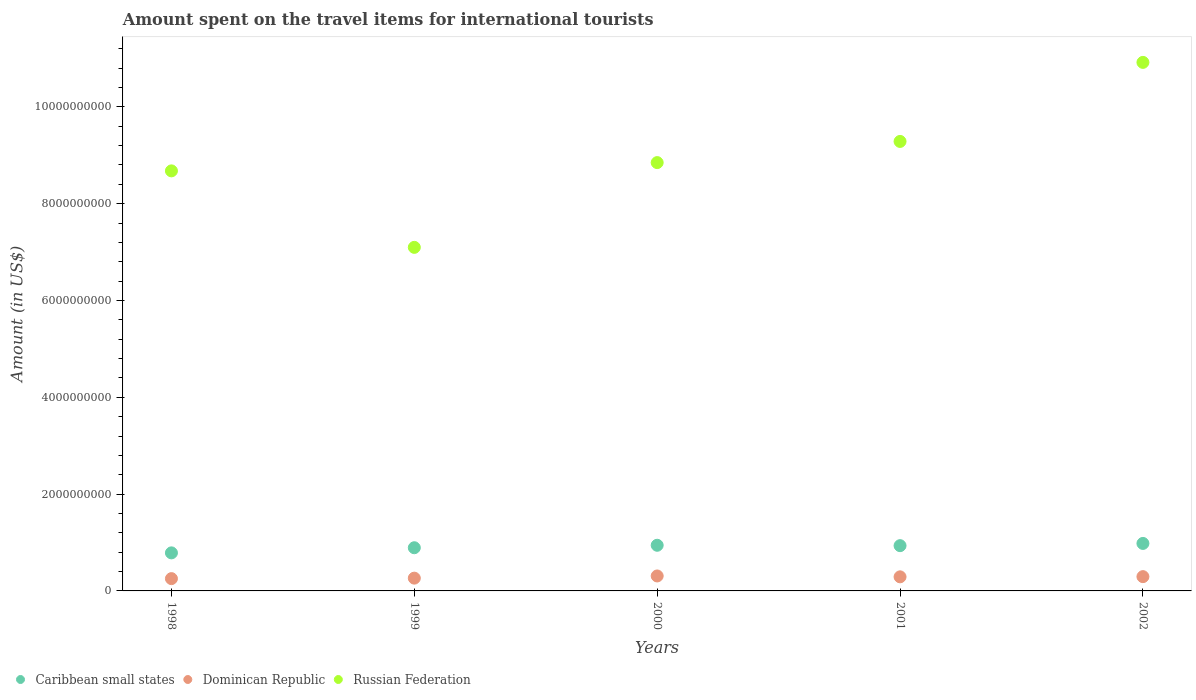How many different coloured dotlines are there?
Provide a short and direct response. 3. What is the amount spent on the travel items for international tourists in Caribbean small states in 2002?
Provide a succinct answer. 9.81e+08. Across all years, what is the maximum amount spent on the travel items for international tourists in Caribbean small states?
Ensure brevity in your answer.  9.81e+08. Across all years, what is the minimum amount spent on the travel items for international tourists in Russian Federation?
Ensure brevity in your answer.  7.10e+09. In which year was the amount spent on the travel items for international tourists in Dominican Republic minimum?
Give a very brief answer. 1998. What is the total amount spent on the travel items for international tourists in Caribbean small states in the graph?
Your answer should be compact. 4.54e+09. What is the difference between the amount spent on the travel items for international tourists in Caribbean small states in 1998 and that in 2002?
Provide a succinct answer. -1.95e+08. What is the difference between the amount spent on the travel items for international tourists in Dominican Republic in 2002 and the amount spent on the travel items for international tourists in Caribbean small states in 2001?
Make the answer very short. -6.40e+08. What is the average amount spent on the travel items for international tourists in Dominican Republic per year?
Give a very brief answer. 2.83e+08. In the year 1999, what is the difference between the amount spent on the travel items for international tourists in Dominican Republic and amount spent on the travel items for international tourists in Russian Federation?
Give a very brief answer. -6.83e+09. What is the ratio of the amount spent on the travel items for international tourists in Dominican Republic in 1999 to that in 2001?
Your response must be concise. 0.91. Is the difference between the amount spent on the travel items for international tourists in Dominican Republic in 2000 and 2001 greater than the difference between the amount spent on the travel items for international tourists in Russian Federation in 2000 and 2001?
Offer a very short reply. Yes. What is the difference between the highest and the second highest amount spent on the travel items for international tourists in Russian Federation?
Provide a succinct answer. 1.63e+09. What is the difference between the highest and the lowest amount spent on the travel items for international tourists in Russian Federation?
Your answer should be compact. 3.82e+09. Is it the case that in every year, the sum of the amount spent on the travel items for international tourists in Russian Federation and amount spent on the travel items for international tourists in Dominican Republic  is greater than the amount spent on the travel items for international tourists in Caribbean small states?
Your response must be concise. Yes. Is the amount spent on the travel items for international tourists in Caribbean small states strictly less than the amount spent on the travel items for international tourists in Russian Federation over the years?
Offer a very short reply. Yes. How many years are there in the graph?
Keep it short and to the point. 5. Are the values on the major ticks of Y-axis written in scientific E-notation?
Ensure brevity in your answer.  No. Does the graph contain any zero values?
Offer a terse response. No. Where does the legend appear in the graph?
Keep it short and to the point. Bottom left. How are the legend labels stacked?
Offer a very short reply. Horizontal. What is the title of the graph?
Provide a succinct answer. Amount spent on the travel items for international tourists. What is the label or title of the X-axis?
Ensure brevity in your answer.  Years. What is the label or title of the Y-axis?
Offer a terse response. Amount (in US$). What is the Amount (in US$) in Caribbean small states in 1998?
Provide a succinct answer. 7.86e+08. What is the Amount (in US$) of Dominican Republic in 1998?
Your answer should be very brief. 2.54e+08. What is the Amount (in US$) of Russian Federation in 1998?
Offer a very short reply. 8.68e+09. What is the Amount (in US$) in Caribbean small states in 1999?
Keep it short and to the point. 8.92e+08. What is the Amount (in US$) in Dominican Republic in 1999?
Give a very brief answer. 2.64e+08. What is the Amount (in US$) of Russian Federation in 1999?
Offer a terse response. 7.10e+09. What is the Amount (in US$) of Caribbean small states in 2000?
Provide a succinct answer. 9.43e+08. What is the Amount (in US$) in Dominican Republic in 2000?
Offer a terse response. 3.09e+08. What is the Amount (in US$) of Russian Federation in 2000?
Your response must be concise. 8.85e+09. What is the Amount (in US$) in Caribbean small states in 2001?
Keep it short and to the point. 9.35e+08. What is the Amount (in US$) of Dominican Republic in 2001?
Ensure brevity in your answer.  2.91e+08. What is the Amount (in US$) of Russian Federation in 2001?
Your answer should be very brief. 9.28e+09. What is the Amount (in US$) of Caribbean small states in 2002?
Your answer should be very brief. 9.81e+08. What is the Amount (in US$) in Dominican Republic in 2002?
Give a very brief answer. 2.95e+08. What is the Amount (in US$) in Russian Federation in 2002?
Provide a short and direct response. 1.09e+1. Across all years, what is the maximum Amount (in US$) of Caribbean small states?
Make the answer very short. 9.81e+08. Across all years, what is the maximum Amount (in US$) of Dominican Republic?
Your answer should be very brief. 3.09e+08. Across all years, what is the maximum Amount (in US$) of Russian Federation?
Your response must be concise. 1.09e+1. Across all years, what is the minimum Amount (in US$) in Caribbean small states?
Offer a very short reply. 7.86e+08. Across all years, what is the minimum Amount (in US$) in Dominican Republic?
Offer a very short reply. 2.54e+08. Across all years, what is the minimum Amount (in US$) in Russian Federation?
Your answer should be compact. 7.10e+09. What is the total Amount (in US$) of Caribbean small states in the graph?
Make the answer very short. 4.54e+09. What is the total Amount (in US$) of Dominican Republic in the graph?
Your answer should be compact. 1.41e+09. What is the total Amount (in US$) of Russian Federation in the graph?
Your response must be concise. 4.48e+1. What is the difference between the Amount (in US$) of Caribbean small states in 1998 and that in 1999?
Provide a succinct answer. -1.06e+08. What is the difference between the Amount (in US$) in Dominican Republic in 1998 and that in 1999?
Your answer should be compact. -1.00e+07. What is the difference between the Amount (in US$) of Russian Federation in 1998 and that in 1999?
Ensure brevity in your answer.  1.58e+09. What is the difference between the Amount (in US$) in Caribbean small states in 1998 and that in 2000?
Keep it short and to the point. -1.57e+08. What is the difference between the Amount (in US$) of Dominican Republic in 1998 and that in 2000?
Keep it short and to the point. -5.50e+07. What is the difference between the Amount (in US$) of Russian Federation in 1998 and that in 2000?
Offer a terse response. -1.71e+08. What is the difference between the Amount (in US$) in Caribbean small states in 1998 and that in 2001?
Provide a short and direct response. -1.49e+08. What is the difference between the Amount (in US$) of Dominican Republic in 1998 and that in 2001?
Your answer should be compact. -3.70e+07. What is the difference between the Amount (in US$) in Russian Federation in 1998 and that in 2001?
Provide a short and direct response. -6.08e+08. What is the difference between the Amount (in US$) in Caribbean small states in 1998 and that in 2002?
Your response must be concise. -1.95e+08. What is the difference between the Amount (in US$) in Dominican Republic in 1998 and that in 2002?
Ensure brevity in your answer.  -4.10e+07. What is the difference between the Amount (in US$) in Russian Federation in 1998 and that in 2002?
Offer a very short reply. -2.24e+09. What is the difference between the Amount (in US$) of Caribbean small states in 1999 and that in 2000?
Provide a short and direct response. -5.10e+07. What is the difference between the Amount (in US$) in Dominican Republic in 1999 and that in 2000?
Offer a very short reply. -4.50e+07. What is the difference between the Amount (in US$) of Russian Federation in 1999 and that in 2000?
Offer a very short reply. -1.75e+09. What is the difference between the Amount (in US$) of Caribbean small states in 1999 and that in 2001?
Offer a very short reply. -4.30e+07. What is the difference between the Amount (in US$) of Dominican Republic in 1999 and that in 2001?
Make the answer very short. -2.70e+07. What is the difference between the Amount (in US$) of Russian Federation in 1999 and that in 2001?
Your answer should be compact. -2.19e+09. What is the difference between the Amount (in US$) of Caribbean small states in 1999 and that in 2002?
Your answer should be very brief. -8.90e+07. What is the difference between the Amount (in US$) in Dominican Republic in 1999 and that in 2002?
Make the answer very short. -3.10e+07. What is the difference between the Amount (in US$) in Russian Federation in 1999 and that in 2002?
Give a very brief answer. -3.82e+09. What is the difference between the Amount (in US$) of Dominican Republic in 2000 and that in 2001?
Provide a succinct answer. 1.80e+07. What is the difference between the Amount (in US$) of Russian Federation in 2000 and that in 2001?
Your answer should be very brief. -4.37e+08. What is the difference between the Amount (in US$) of Caribbean small states in 2000 and that in 2002?
Offer a terse response. -3.80e+07. What is the difference between the Amount (in US$) in Dominican Republic in 2000 and that in 2002?
Provide a succinct answer. 1.40e+07. What is the difference between the Amount (in US$) in Russian Federation in 2000 and that in 2002?
Your answer should be very brief. -2.07e+09. What is the difference between the Amount (in US$) of Caribbean small states in 2001 and that in 2002?
Make the answer very short. -4.60e+07. What is the difference between the Amount (in US$) of Russian Federation in 2001 and that in 2002?
Provide a short and direct response. -1.63e+09. What is the difference between the Amount (in US$) in Caribbean small states in 1998 and the Amount (in US$) in Dominican Republic in 1999?
Offer a terse response. 5.22e+08. What is the difference between the Amount (in US$) of Caribbean small states in 1998 and the Amount (in US$) of Russian Federation in 1999?
Your answer should be very brief. -6.31e+09. What is the difference between the Amount (in US$) of Dominican Republic in 1998 and the Amount (in US$) of Russian Federation in 1999?
Ensure brevity in your answer.  -6.84e+09. What is the difference between the Amount (in US$) in Caribbean small states in 1998 and the Amount (in US$) in Dominican Republic in 2000?
Ensure brevity in your answer.  4.77e+08. What is the difference between the Amount (in US$) of Caribbean small states in 1998 and the Amount (in US$) of Russian Federation in 2000?
Offer a very short reply. -8.06e+09. What is the difference between the Amount (in US$) of Dominican Republic in 1998 and the Amount (in US$) of Russian Federation in 2000?
Your answer should be compact. -8.59e+09. What is the difference between the Amount (in US$) of Caribbean small states in 1998 and the Amount (in US$) of Dominican Republic in 2001?
Give a very brief answer. 4.95e+08. What is the difference between the Amount (in US$) in Caribbean small states in 1998 and the Amount (in US$) in Russian Federation in 2001?
Your answer should be compact. -8.50e+09. What is the difference between the Amount (in US$) of Dominican Republic in 1998 and the Amount (in US$) of Russian Federation in 2001?
Your answer should be very brief. -9.03e+09. What is the difference between the Amount (in US$) in Caribbean small states in 1998 and the Amount (in US$) in Dominican Republic in 2002?
Your answer should be very brief. 4.91e+08. What is the difference between the Amount (in US$) of Caribbean small states in 1998 and the Amount (in US$) of Russian Federation in 2002?
Give a very brief answer. -1.01e+1. What is the difference between the Amount (in US$) in Dominican Republic in 1998 and the Amount (in US$) in Russian Federation in 2002?
Make the answer very short. -1.07e+1. What is the difference between the Amount (in US$) of Caribbean small states in 1999 and the Amount (in US$) of Dominican Republic in 2000?
Offer a terse response. 5.83e+08. What is the difference between the Amount (in US$) in Caribbean small states in 1999 and the Amount (in US$) in Russian Federation in 2000?
Make the answer very short. -7.96e+09. What is the difference between the Amount (in US$) in Dominican Republic in 1999 and the Amount (in US$) in Russian Federation in 2000?
Ensure brevity in your answer.  -8.58e+09. What is the difference between the Amount (in US$) of Caribbean small states in 1999 and the Amount (in US$) of Dominican Republic in 2001?
Your response must be concise. 6.01e+08. What is the difference between the Amount (in US$) of Caribbean small states in 1999 and the Amount (in US$) of Russian Federation in 2001?
Your answer should be compact. -8.39e+09. What is the difference between the Amount (in US$) of Dominican Republic in 1999 and the Amount (in US$) of Russian Federation in 2001?
Your answer should be very brief. -9.02e+09. What is the difference between the Amount (in US$) in Caribbean small states in 1999 and the Amount (in US$) in Dominican Republic in 2002?
Your answer should be compact. 5.97e+08. What is the difference between the Amount (in US$) in Caribbean small states in 1999 and the Amount (in US$) in Russian Federation in 2002?
Keep it short and to the point. -1.00e+1. What is the difference between the Amount (in US$) of Dominican Republic in 1999 and the Amount (in US$) of Russian Federation in 2002?
Offer a very short reply. -1.07e+1. What is the difference between the Amount (in US$) of Caribbean small states in 2000 and the Amount (in US$) of Dominican Republic in 2001?
Offer a very short reply. 6.52e+08. What is the difference between the Amount (in US$) in Caribbean small states in 2000 and the Amount (in US$) in Russian Federation in 2001?
Provide a succinct answer. -8.34e+09. What is the difference between the Amount (in US$) in Dominican Republic in 2000 and the Amount (in US$) in Russian Federation in 2001?
Provide a succinct answer. -8.98e+09. What is the difference between the Amount (in US$) of Caribbean small states in 2000 and the Amount (in US$) of Dominican Republic in 2002?
Your answer should be very brief. 6.48e+08. What is the difference between the Amount (in US$) of Caribbean small states in 2000 and the Amount (in US$) of Russian Federation in 2002?
Your response must be concise. -9.98e+09. What is the difference between the Amount (in US$) in Dominican Republic in 2000 and the Amount (in US$) in Russian Federation in 2002?
Give a very brief answer. -1.06e+1. What is the difference between the Amount (in US$) of Caribbean small states in 2001 and the Amount (in US$) of Dominican Republic in 2002?
Offer a very short reply. 6.40e+08. What is the difference between the Amount (in US$) in Caribbean small states in 2001 and the Amount (in US$) in Russian Federation in 2002?
Offer a very short reply. -9.98e+09. What is the difference between the Amount (in US$) in Dominican Republic in 2001 and the Amount (in US$) in Russian Federation in 2002?
Make the answer very short. -1.06e+1. What is the average Amount (in US$) in Caribbean small states per year?
Give a very brief answer. 9.07e+08. What is the average Amount (in US$) of Dominican Republic per year?
Provide a succinct answer. 2.83e+08. What is the average Amount (in US$) in Russian Federation per year?
Your answer should be compact. 8.96e+09. In the year 1998, what is the difference between the Amount (in US$) of Caribbean small states and Amount (in US$) of Dominican Republic?
Give a very brief answer. 5.32e+08. In the year 1998, what is the difference between the Amount (in US$) in Caribbean small states and Amount (in US$) in Russian Federation?
Provide a succinct answer. -7.89e+09. In the year 1998, what is the difference between the Amount (in US$) of Dominican Republic and Amount (in US$) of Russian Federation?
Your answer should be very brief. -8.42e+09. In the year 1999, what is the difference between the Amount (in US$) in Caribbean small states and Amount (in US$) in Dominican Republic?
Keep it short and to the point. 6.28e+08. In the year 1999, what is the difference between the Amount (in US$) in Caribbean small states and Amount (in US$) in Russian Federation?
Your response must be concise. -6.20e+09. In the year 1999, what is the difference between the Amount (in US$) of Dominican Republic and Amount (in US$) of Russian Federation?
Give a very brief answer. -6.83e+09. In the year 2000, what is the difference between the Amount (in US$) in Caribbean small states and Amount (in US$) in Dominican Republic?
Give a very brief answer. 6.34e+08. In the year 2000, what is the difference between the Amount (in US$) in Caribbean small states and Amount (in US$) in Russian Federation?
Give a very brief answer. -7.90e+09. In the year 2000, what is the difference between the Amount (in US$) in Dominican Republic and Amount (in US$) in Russian Federation?
Ensure brevity in your answer.  -8.54e+09. In the year 2001, what is the difference between the Amount (in US$) in Caribbean small states and Amount (in US$) in Dominican Republic?
Ensure brevity in your answer.  6.44e+08. In the year 2001, what is the difference between the Amount (in US$) of Caribbean small states and Amount (in US$) of Russian Federation?
Offer a terse response. -8.35e+09. In the year 2001, what is the difference between the Amount (in US$) in Dominican Republic and Amount (in US$) in Russian Federation?
Offer a terse response. -8.99e+09. In the year 2002, what is the difference between the Amount (in US$) in Caribbean small states and Amount (in US$) in Dominican Republic?
Provide a short and direct response. 6.86e+08. In the year 2002, what is the difference between the Amount (in US$) in Caribbean small states and Amount (in US$) in Russian Federation?
Ensure brevity in your answer.  -9.94e+09. In the year 2002, what is the difference between the Amount (in US$) in Dominican Republic and Amount (in US$) in Russian Federation?
Keep it short and to the point. -1.06e+1. What is the ratio of the Amount (in US$) of Caribbean small states in 1998 to that in 1999?
Provide a succinct answer. 0.88. What is the ratio of the Amount (in US$) of Dominican Republic in 1998 to that in 1999?
Your response must be concise. 0.96. What is the ratio of the Amount (in US$) of Russian Federation in 1998 to that in 1999?
Offer a terse response. 1.22. What is the ratio of the Amount (in US$) of Caribbean small states in 1998 to that in 2000?
Offer a very short reply. 0.83. What is the ratio of the Amount (in US$) of Dominican Republic in 1998 to that in 2000?
Offer a terse response. 0.82. What is the ratio of the Amount (in US$) of Russian Federation in 1998 to that in 2000?
Provide a short and direct response. 0.98. What is the ratio of the Amount (in US$) of Caribbean small states in 1998 to that in 2001?
Offer a terse response. 0.84. What is the ratio of the Amount (in US$) in Dominican Republic in 1998 to that in 2001?
Provide a short and direct response. 0.87. What is the ratio of the Amount (in US$) of Russian Federation in 1998 to that in 2001?
Keep it short and to the point. 0.93. What is the ratio of the Amount (in US$) in Caribbean small states in 1998 to that in 2002?
Your response must be concise. 0.8. What is the ratio of the Amount (in US$) of Dominican Republic in 1998 to that in 2002?
Keep it short and to the point. 0.86. What is the ratio of the Amount (in US$) in Russian Federation in 1998 to that in 2002?
Provide a short and direct response. 0.79. What is the ratio of the Amount (in US$) in Caribbean small states in 1999 to that in 2000?
Give a very brief answer. 0.95. What is the ratio of the Amount (in US$) in Dominican Republic in 1999 to that in 2000?
Give a very brief answer. 0.85. What is the ratio of the Amount (in US$) of Russian Federation in 1999 to that in 2000?
Provide a succinct answer. 0.8. What is the ratio of the Amount (in US$) in Caribbean small states in 1999 to that in 2001?
Keep it short and to the point. 0.95. What is the ratio of the Amount (in US$) of Dominican Republic in 1999 to that in 2001?
Offer a terse response. 0.91. What is the ratio of the Amount (in US$) of Russian Federation in 1999 to that in 2001?
Provide a short and direct response. 0.76. What is the ratio of the Amount (in US$) in Caribbean small states in 1999 to that in 2002?
Provide a short and direct response. 0.91. What is the ratio of the Amount (in US$) in Dominican Republic in 1999 to that in 2002?
Provide a short and direct response. 0.89. What is the ratio of the Amount (in US$) in Russian Federation in 1999 to that in 2002?
Give a very brief answer. 0.65. What is the ratio of the Amount (in US$) of Caribbean small states in 2000 to that in 2001?
Your answer should be compact. 1.01. What is the ratio of the Amount (in US$) of Dominican Republic in 2000 to that in 2001?
Your answer should be compact. 1.06. What is the ratio of the Amount (in US$) in Russian Federation in 2000 to that in 2001?
Provide a short and direct response. 0.95. What is the ratio of the Amount (in US$) of Caribbean small states in 2000 to that in 2002?
Make the answer very short. 0.96. What is the ratio of the Amount (in US$) of Dominican Republic in 2000 to that in 2002?
Offer a very short reply. 1.05. What is the ratio of the Amount (in US$) of Russian Federation in 2000 to that in 2002?
Provide a short and direct response. 0.81. What is the ratio of the Amount (in US$) of Caribbean small states in 2001 to that in 2002?
Your answer should be very brief. 0.95. What is the ratio of the Amount (in US$) in Dominican Republic in 2001 to that in 2002?
Your answer should be very brief. 0.99. What is the ratio of the Amount (in US$) in Russian Federation in 2001 to that in 2002?
Ensure brevity in your answer.  0.85. What is the difference between the highest and the second highest Amount (in US$) of Caribbean small states?
Make the answer very short. 3.80e+07. What is the difference between the highest and the second highest Amount (in US$) of Dominican Republic?
Offer a very short reply. 1.40e+07. What is the difference between the highest and the second highest Amount (in US$) in Russian Federation?
Offer a very short reply. 1.63e+09. What is the difference between the highest and the lowest Amount (in US$) in Caribbean small states?
Keep it short and to the point. 1.95e+08. What is the difference between the highest and the lowest Amount (in US$) of Dominican Republic?
Keep it short and to the point. 5.50e+07. What is the difference between the highest and the lowest Amount (in US$) in Russian Federation?
Give a very brief answer. 3.82e+09. 